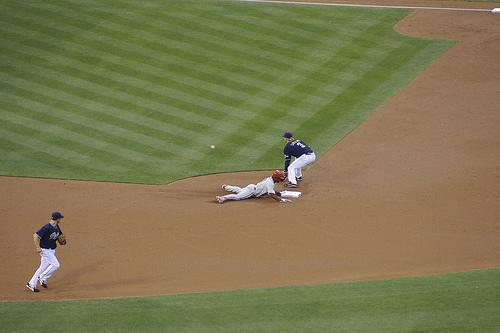How many people?
Give a very brief answer. 3. 